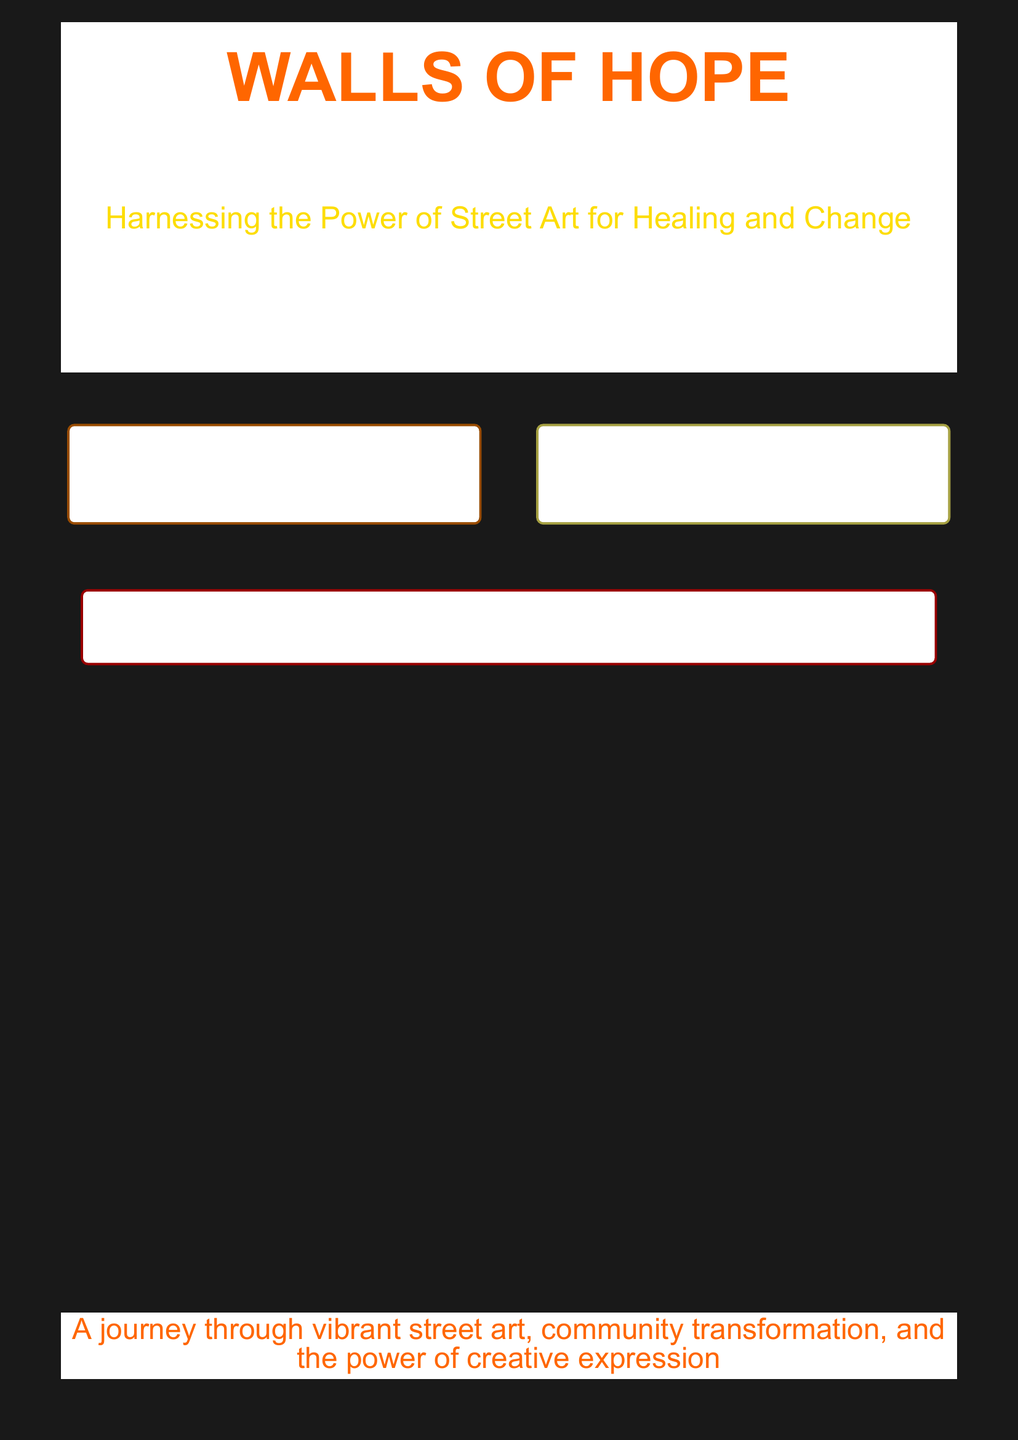What is the title of the book? The title is prominently displayed at the top of the document and is "WALLS OF HOPE."
Answer: WALLS OF HOPE Who is the author of the book? The author's name is stated below the title, which is "Connor Davis."
Answer: Connor Davis What is the subtitle of the book? The subtitle is included just below the title in smaller font and is "How Street Art Transforms Lives and Communities."
Answer: How Street Art Transforms Lives and Communities What is one key theme of the book? The description boxes highlight key themes, one being the use of street art in raising awareness about addiction and recovery.
Answer: Raising awareness about addiction and recovery Which two notable artists are mentioned in the document? The text specifically lists "Shepard Fairey" and "Banksy" as artists who address social issues.
Answer: Shepard Fairey and Banksy What color is used for the title's text? The title's text is in orange, as seen in the font color details of the document.
Answer: Orange How does the book describe the impact of street art? The description mentions that street art "provides therapeutic outlets and sparks conversations about recovery."
Answer: Provides therapeutic outlets and sparks conversations about recovery What type of transformations does the book explore? The text indicates that the book explores "community transformation" through street art.
Answer: Community transformation What size font is used for the author's name? The author's name is presented in a font size of 28, according to the formatting details.
Answer: 28 